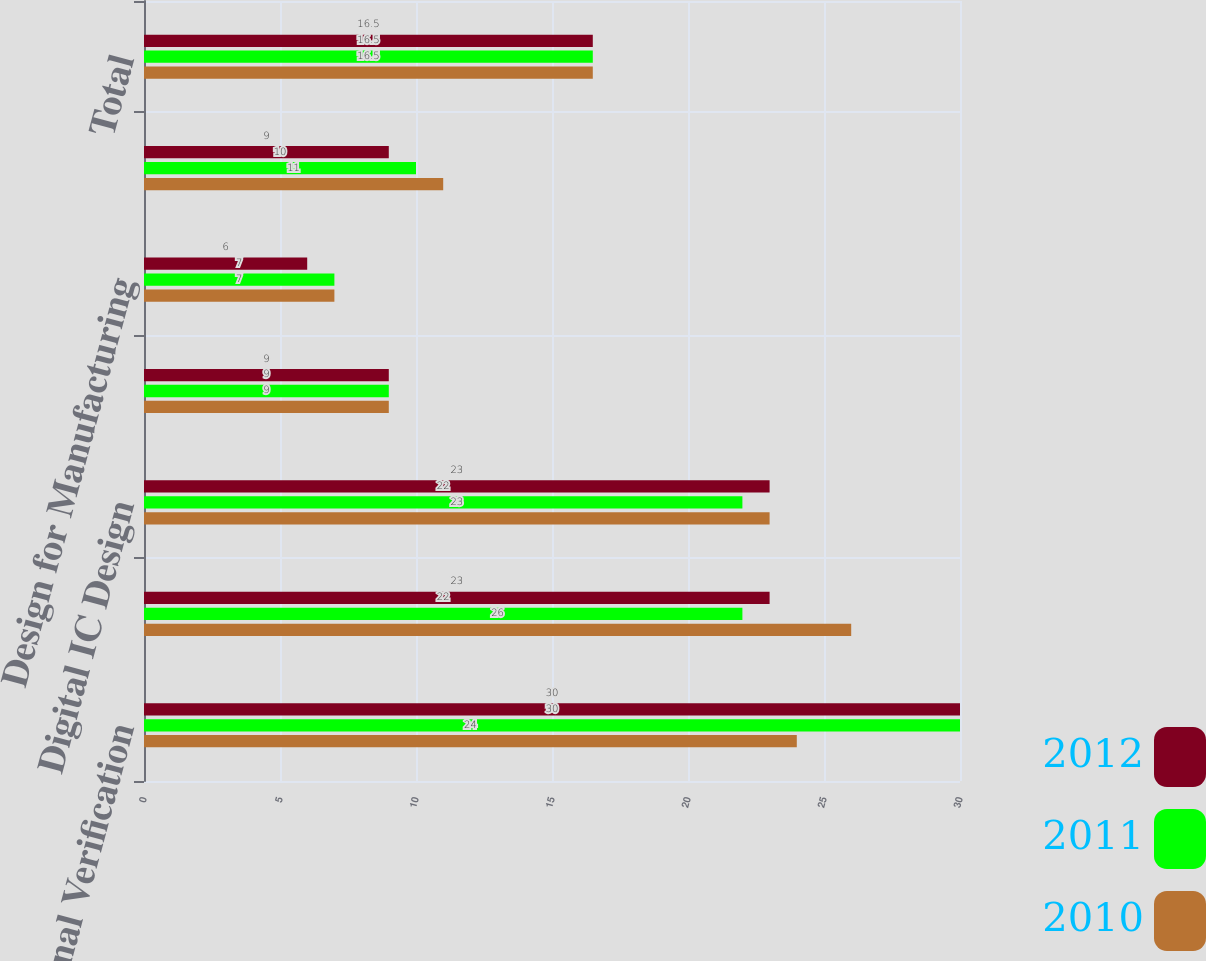Convert chart. <chart><loc_0><loc_0><loc_500><loc_500><stacked_bar_chart><ecel><fcel>Functional Verification<fcel>Custom IC Design<fcel>Digital IC Design<fcel>System Interconnect Design<fcel>Design for Manufacturing<fcel>Services and other<fcel>Total<nl><fcel>2012<fcel>30<fcel>23<fcel>23<fcel>9<fcel>6<fcel>9<fcel>16.5<nl><fcel>2011<fcel>30<fcel>22<fcel>22<fcel>9<fcel>7<fcel>10<fcel>16.5<nl><fcel>2010<fcel>24<fcel>26<fcel>23<fcel>9<fcel>7<fcel>11<fcel>16.5<nl></chart> 